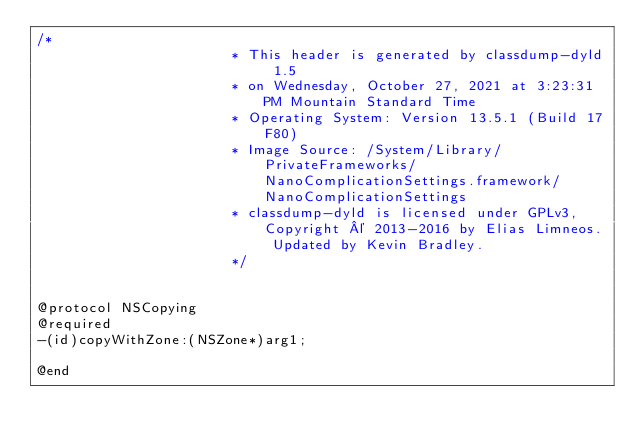<code> <loc_0><loc_0><loc_500><loc_500><_C_>/*
                       * This header is generated by classdump-dyld 1.5
                       * on Wednesday, October 27, 2021 at 3:23:31 PM Mountain Standard Time
                       * Operating System: Version 13.5.1 (Build 17F80)
                       * Image Source: /System/Library/PrivateFrameworks/NanoComplicationSettings.framework/NanoComplicationSettings
                       * classdump-dyld is licensed under GPLv3, Copyright © 2013-2016 by Elias Limneos. Updated by Kevin Bradley.
                       */


@protocol NSCopying
@required
-(id)copyWithZone:(NSZone*)arg1;

@end

</code> 